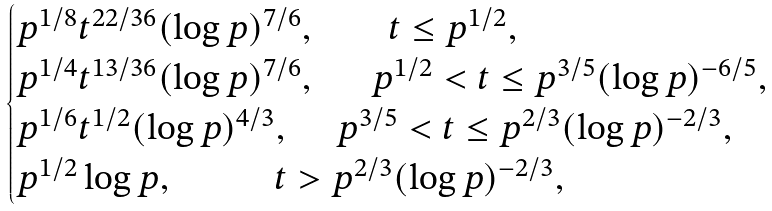<formula> <loc_0><loc_0><loc_500><loc_500>\begin{cases} p ^ { 1 / 8 } t ^ { 2 2 / 3 6 } ( \log { p } ) ^ { 7 / 6 } , \quad \ \ \ \ t \leq p ^ { 1 / 2 } , \\ p ^ { 1 / 4 } t ^ { 1 3 / 3 6 } ( \log { p } ) ^ { 7 / 6 } , \quad \ \ p ^ { 1 / 2 } < t \leq p ^ { 3 / 5 } ( \log { p } ) ^ { - 6 / 5 } , \\ p ^ { 1 / 6 } t ^ { 1 / 2 } ( \log { p } ) ^ { 4 / 3 } , \quad \ p ^ { 3 / 5 } < t \leq p ^ { 2 / 3 } ( \log { p } ) ^ { - 2 / 3 } , \\ p ^ { 1 / 2 } \log { p } , \quad \ \quad \ \ t > p ^ { 2 / 3 } ( \log { p } ) ^ { - 2 / 3 } , \end{cases}</formula> 